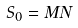Convert formula to latex. <formula><loc_0><loc_0><loc_500><loc_500>S _ { 0 } = M N</formula> 